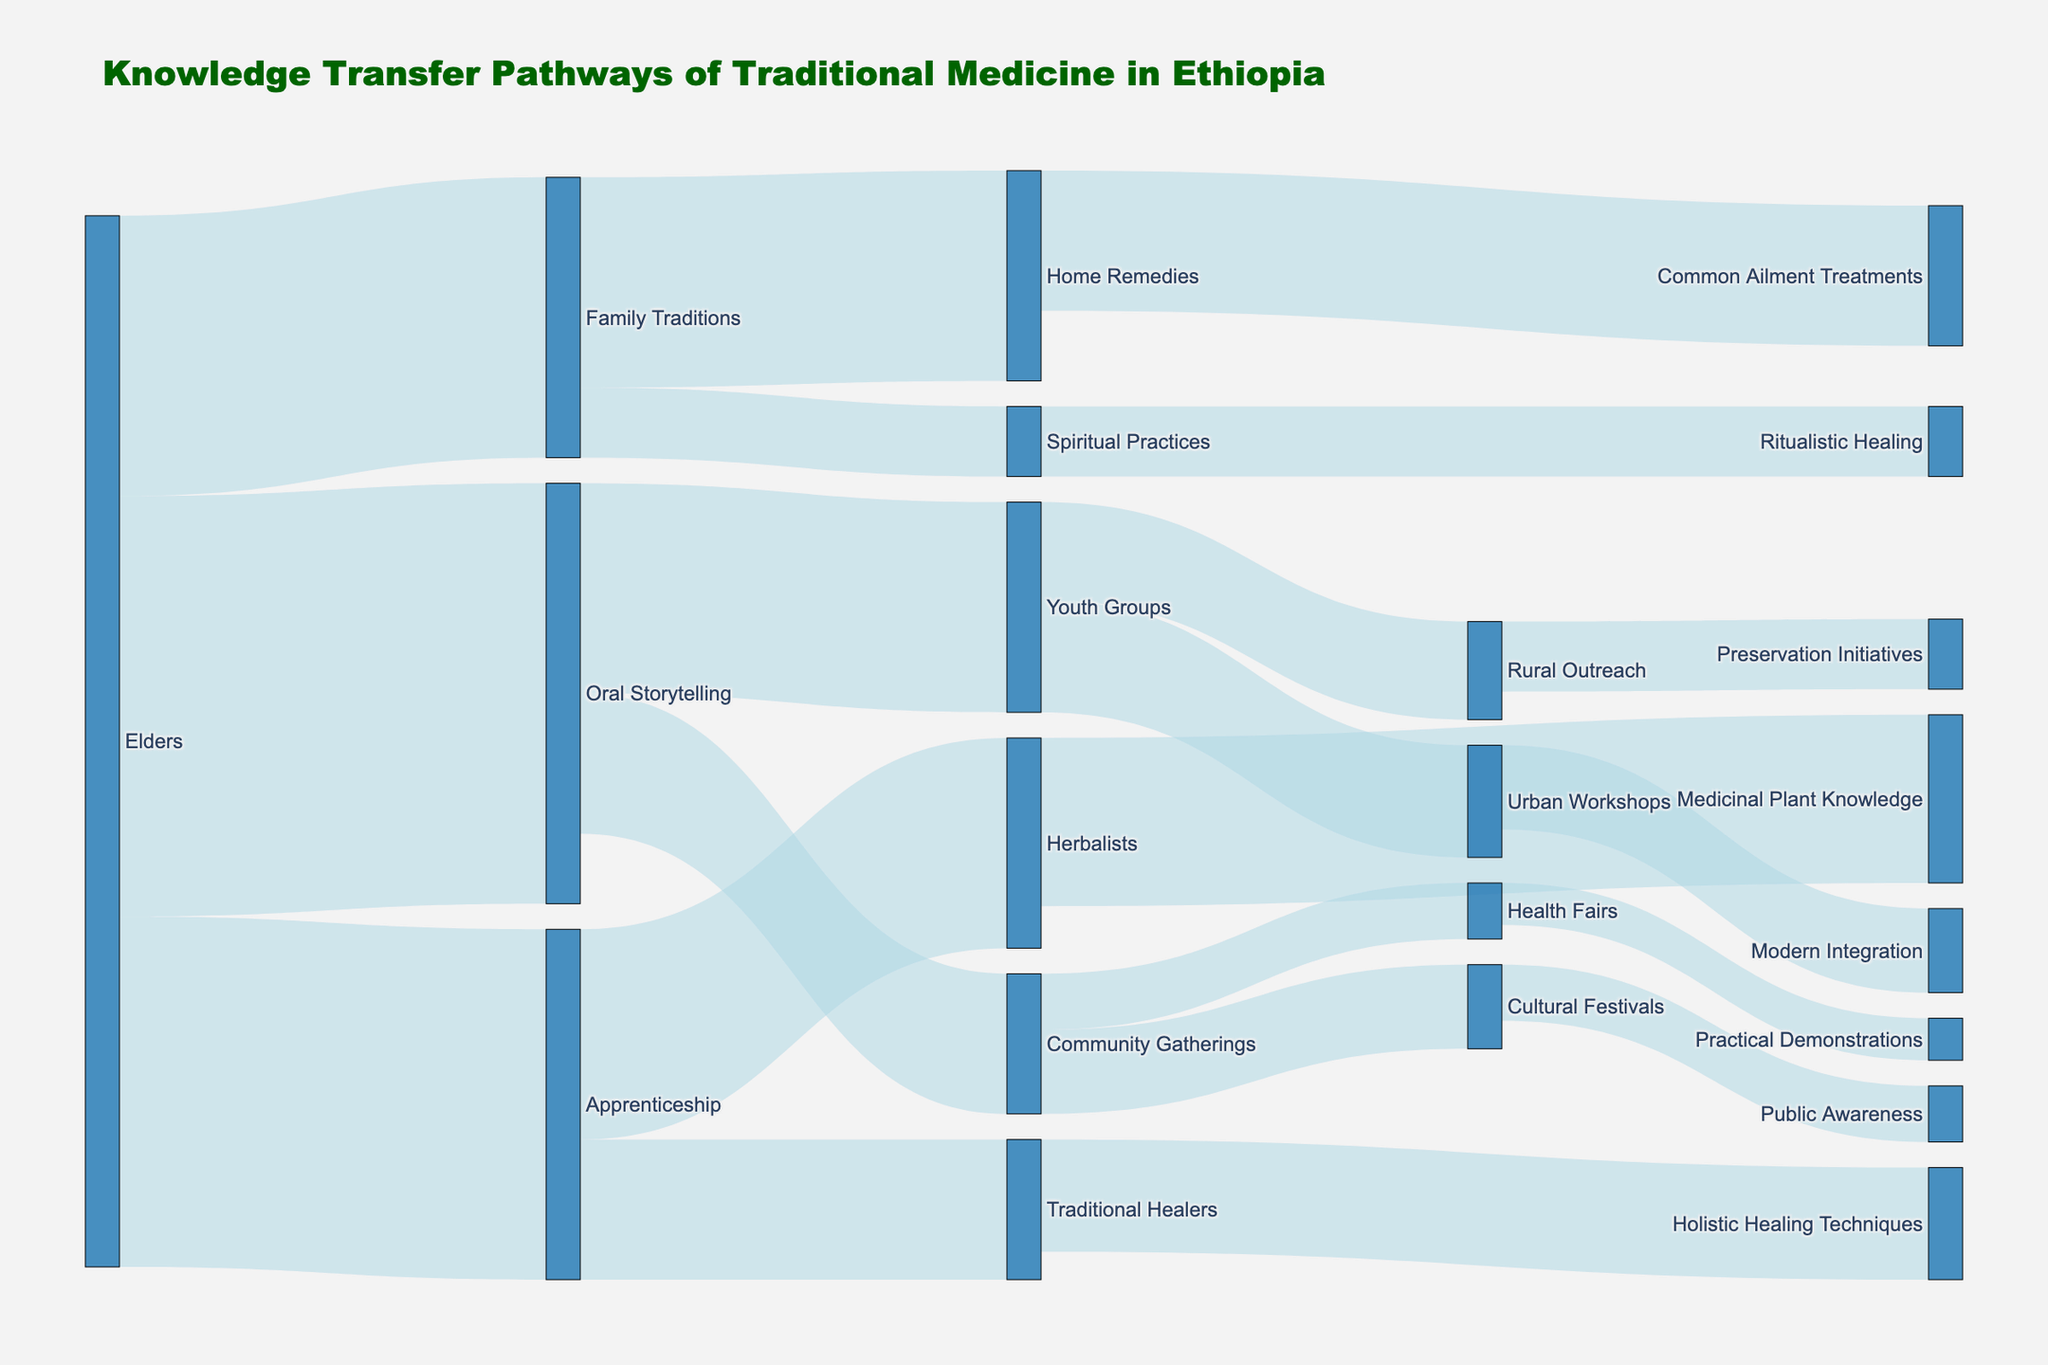What's the title of the figure? The title is usually displayed at the top of the figure and provides a summary of the content.
Answer: Knowledge Transfer Pathways of Traditional Medicine in Ethiopia How many pathways originate from 'Elders'? Count the links that start from the 'Elders' node.
Answer: 3 Which group received the most knowledge through 'Family Traditions'? Identify the target nodes linked from 'Family Traditions' and compare their values.
Answer: Home Remedies What is the total value of knowledge transferred through 'Oral Storytelling'? Sum up the values of all links originating from 'Oral Storytelling'.
Answer: 25 Compare the value of knowledge transferred to 'Herbalists' and 'Traditional Healers' through 'Apprenticeship'. Which is greater? Find the values of links from 'Apprenticeship' to 'Herbalists' and 'Traditional Healers' and compare them.
Answer: Herbalists What is the combined value of knowledge transferred to 'Urban Workshops' and 'Rural Outreach'? Sum the values of links going to 'Urban Workshops' and 'Rural Outreach'.
Answer: 15 Describe how knowledge related to 'Spiritual Practices' is transferred. Identify the pathway that leads to 'Spiritual Practices' and the subsequent path it connects to.
Answer: Elders → Family Traditions → Spiritual Practices → Ritualistic Healing Which pathway has the smallest value, and what is that value? Identify the link with the smallest value by comparing all values.
Answer: Health Fairs (3) How many nodes are in the Sankey Diagram? Count all unique nodes in the diagram.
Answer: 16 